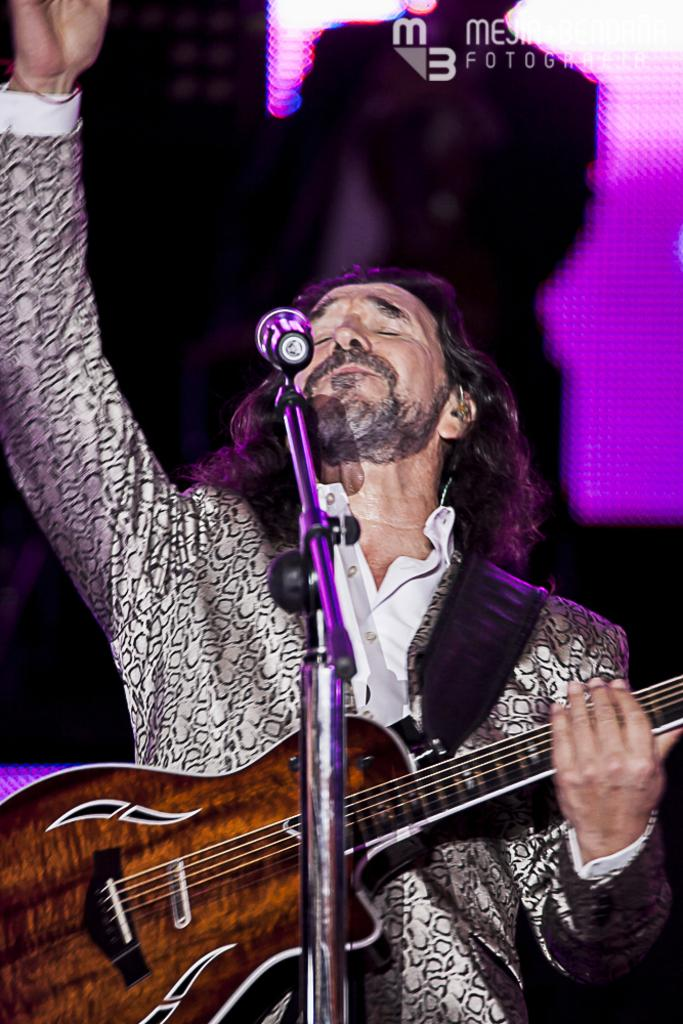What is the main subject of the image? The main subject of the image is a man. What is the man doing in the image? The man is holding a music instrument and singing into a microphone. Can you describe the music instrument the man is holding? The music instrument is brown in color. What type of berry is the man holding in the image? There is no berry present in the image; the man is holding a music instrument. 